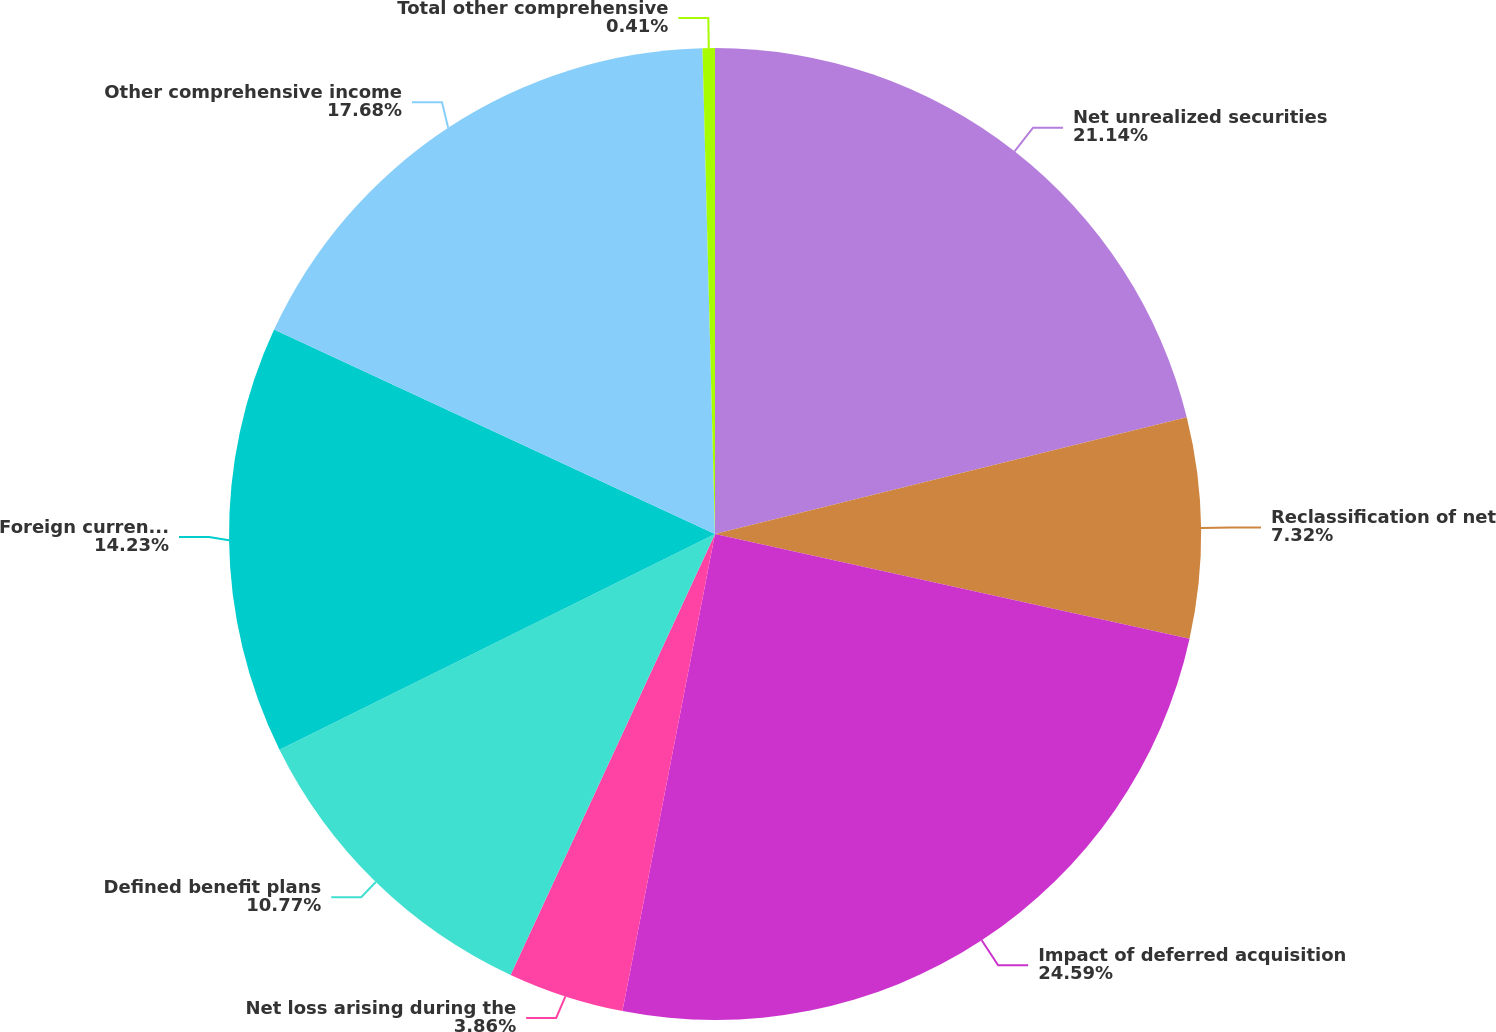Convert chart. <chart><loc_0><loc_0><loc_500><loc_500><pie_chart><fcel>Net unrealized securities<fcel>Reclassification of net<fcel>Impact of deferred acquisition<fcel>Net loss arising during the<fcel>Defined benefit plans<fcel>Foreign currency translation<fcel>Other comprehensive income<fcel>Total other comprehensive<nl><fcel>21.14%<fcel>7.32%<fcel>24.59%<fcel>3.86%<fcel>10.77%<fcel>14.23%<fcel>17.68%<fcel>0.41%<nl></chart> 